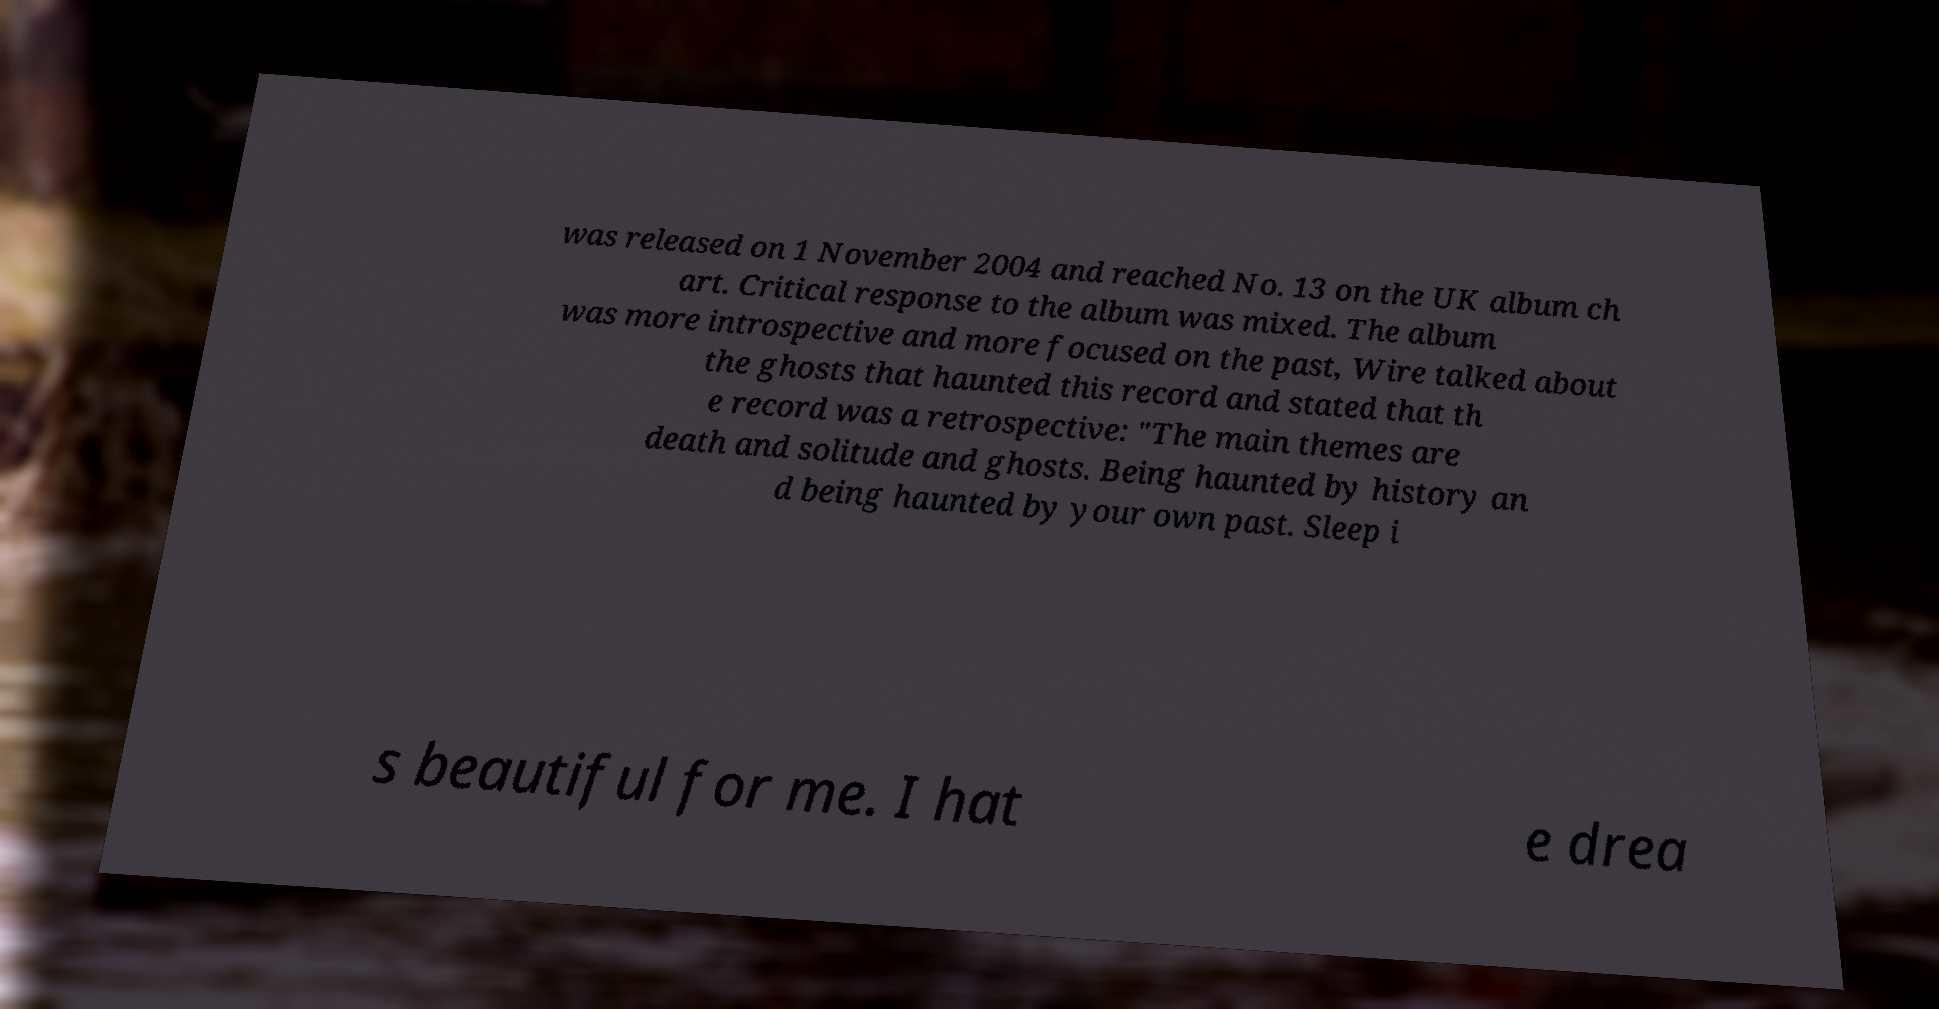I need the written content from this picture converted into text. Can you do that? was released on 1 November 2004 and reached No. 13 on the UK album ch art. Critical response to the album was mixed. The album was more introspective and more focused on the past, Wire talked about the ghosts that haunted this record and stated that th e record was a retrospective: "The main themes are death and solitude and ghosts. Being haunted by history an d being haunted by your own past. Sleep i s beautiful for me. I hat e drea 